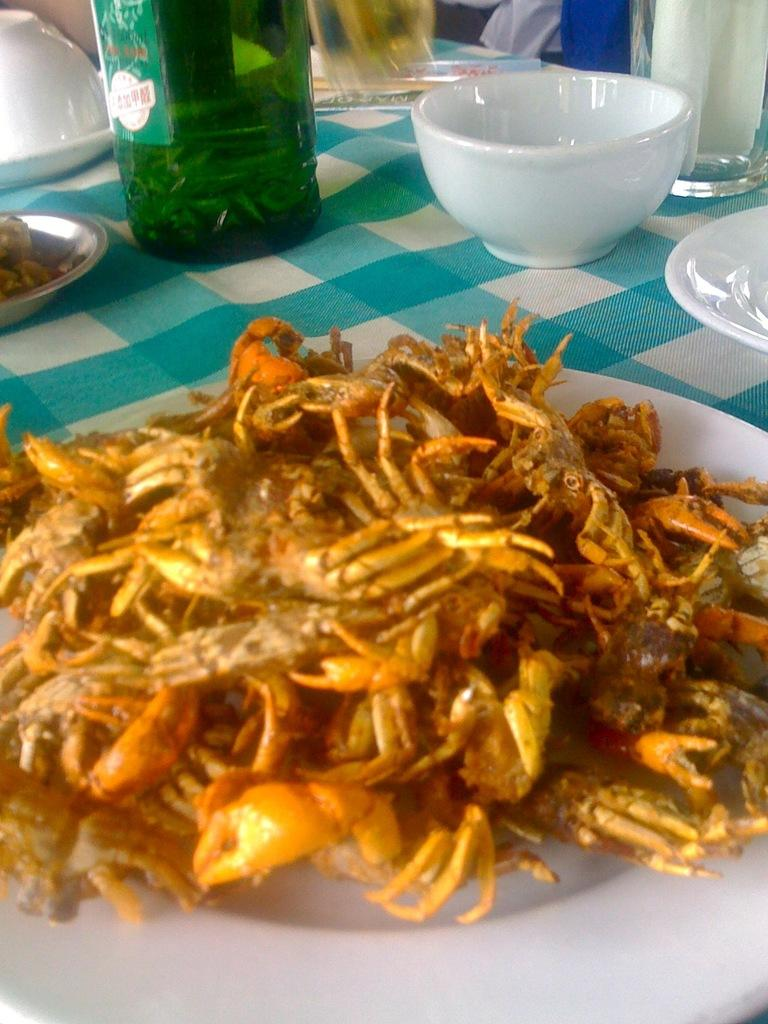What is on the plate that is visible in the image? There is a plate full of crabs in the image. Where is the plate located in the image? The plate is on a table in the image. What other items can be seen on the table in the image? There are bowls, a glass bottle, and glasses on the table in the image. How many plates are visible on the table in the image? There is one plate visible on the table in the image. What book is being read by the crabs in the image? There is no book present in the image, and the crabs are not shown to be reading anything. 